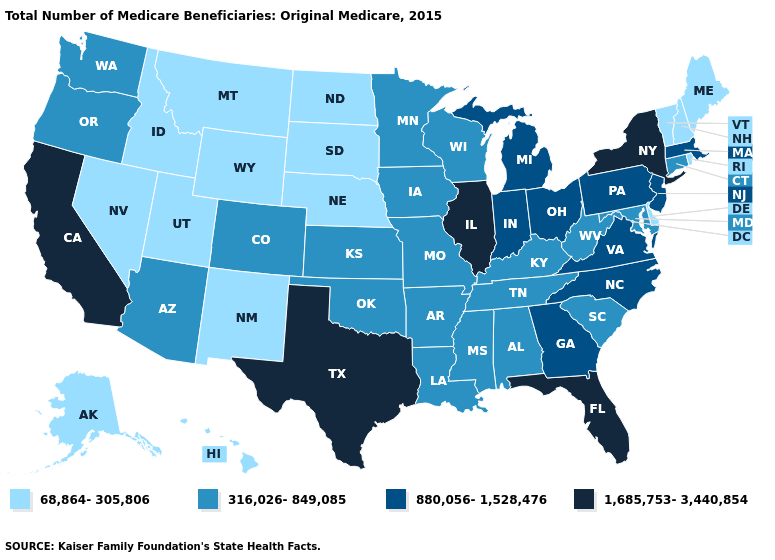Does Illinois have the highest value in the USA?
Short answer required. Yes. Does California have a lower value than Arizona?
Concise answer only. No. Is the legend a continuous bar?
Answer briefly. No. Does California have the highest value in the West?
Concise answer only. Yes. What is the value of Kansas?
Be succinct. 316,026-849,085. Does Arizona have the lowest value in the West?
Quick response, please. No. What is the value of West Virginia?
Write a very short answer. 316,026-849,085. What is the value of New York?
Be succinct. 1,685,753-3,440,854. What is the lowest value in states that border Louisiana?
Concise answer only. 316,026-849,085. Does Oklahoma have the lowest value in the USA?
Short answer required. No. Does California have the lowest value in the West?
Quick response, please. No. Does California have the highest value in the USA?
Give a very brief answer. Yes. What is the lowest value in the USA?
Concise answer only. 68,864-305,806. Does the first symbol in the legend represent the smallest category?
Quick response, please. Yes. How many symbols are there in the legend?
Short answer required. 4. 